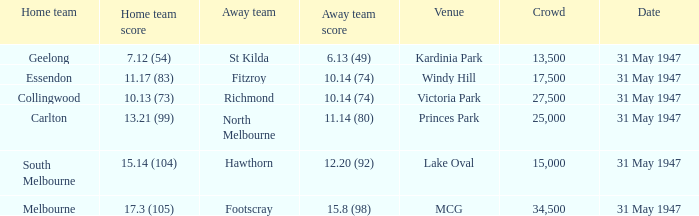What is the home team's score at mcg? 17.3 (105). 